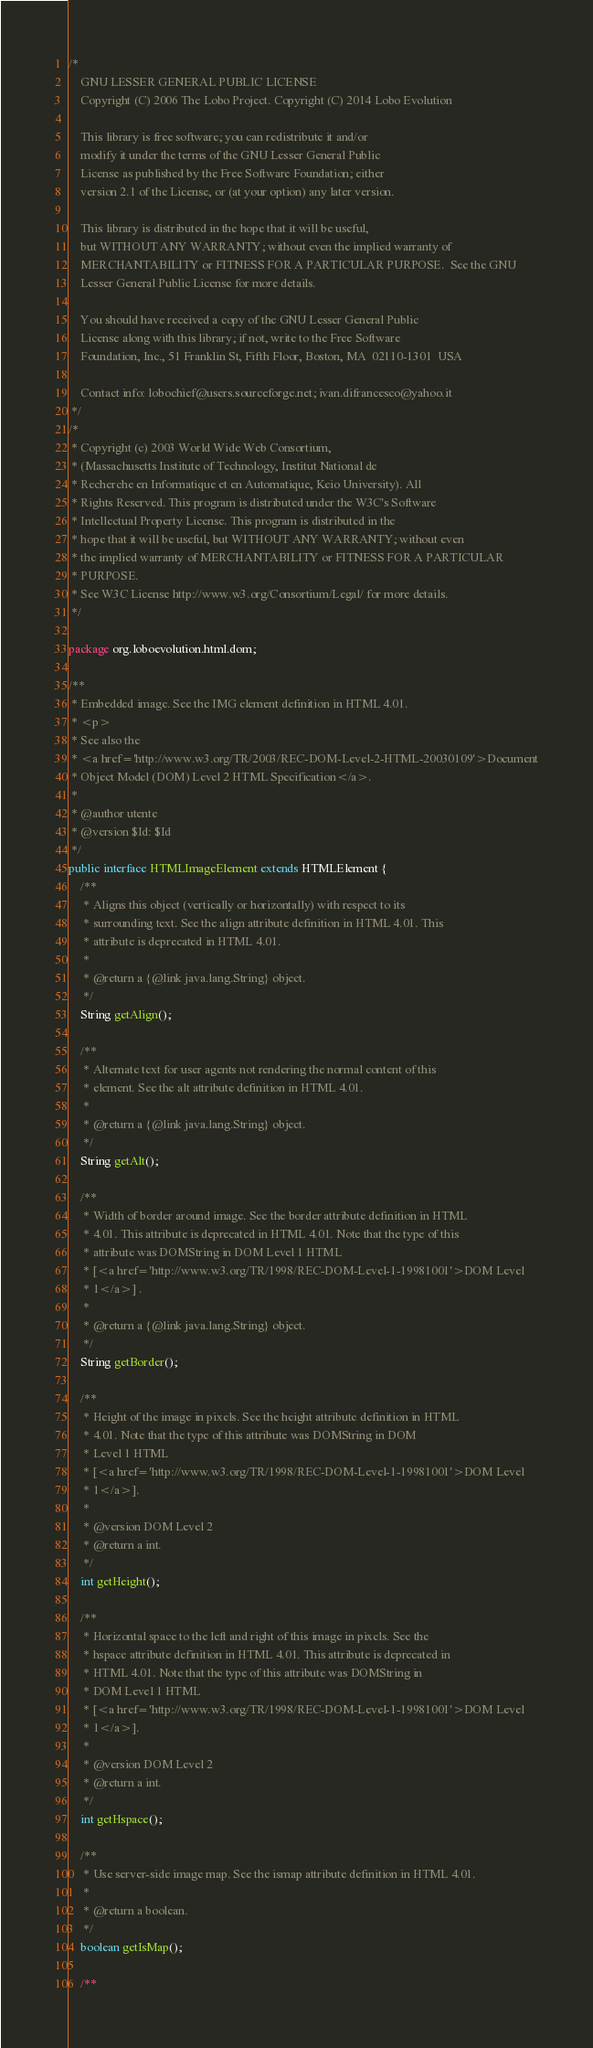Convert code to text. <code><loc_0><loc_0><loc_500><loc_500><_Java_>/*
    GNU LESSER GENERAL PUBLIC LICENSE
    Copyright (C) 2006 The Lobo Project. Copyright (C) 2014 Lobo Evolution

    This library is free software; you can redistribute it and/or
    modify it under the terms of the GNU Lesser General Public
    License as published by the Free Software Foundation; either
    version 2.1 of the License, or (at your option) any later version.

    This library is distributed in the hope that it will be useful,
    but WITHOUT ANY WARRANTY; without even the implied warranty of
    MERCHANTABILITY or FITNESS FOR A PARTICULAR PURPOSE.  See the GNU
    Lesser General Public License for more details.

    You should have received a copy of the GNU Lesser General Public
    License along with this library; if not, write to the Free Software
    Foundation, Inc., 51 Franklin St, Fifth Floor, Boston, MA  02110-1301  USA

    Contact info: lobochief@users.sourceforge.net; ivan.difrancesco@yahoo.it
 */
/*
 * Copyright (c) 2003 World Wide Web Consortium,
 * (Massachusetts Institute of Technology, Institut National de
 * Recherche en Informatique et en Automatique, Keio University). All
 * Rights Reserved. This program is distributed under the W3C's Software
 * Intellectual Property License. This program is distributed in the
 * hope that it will be useful, but WITHOUT ANY WARRANTY; without even
 * the implied warranty of MERCHANTABILITY or FITNESS FOR A PARTICULAR
 * PURPOSE.
 * See W3C License http://www.w3.org/Consortium/Legal/ for more details.
 */

package org.loboevolution.html.dom;

/**
 * Embedded image. See the IMG element definition in HTML 4.01.
 * <p>
 * See also the
 * <a href='http://www.w3.org/TR/2003/REC-DOM-Level-2-HTML-20030109'>Document
 * Object Model (DOM) Level 2 HTML Specification</a>.
 *
 * @author utente
 * @version $Id: $Id
 */
public interface HTMLImageElement extends HTMLElement {
	/**
	 * Aligns this object (vertically or horizontally) with respect to its
	 * surrounding text. See the align attribute definition in HTML 4.01. This
	 * attribute is deprecated in HTML 4.01.
	 *
	 * @return a {@link java.lang.String} object.
	 */
	String getAlign();

	/**
	 * Alternate text for user agents not rendering the normal content of this
	 * element. See the alt attribute definition in HTML 4.01.
	 *
	 * @return a {@link java.lang.String} object.
	 */
	String getAlt();

	/**
	 * Width of border around image. See the border attribute definition in HTML
	 * 4.01. This attribute is deprecated in HTML 4.01. Note that the type of this
	 * attribute was DOMString in DOM Level 1 HTML
	 * [<a href='http://www.w3.org/TR/1998/REC-DOM-Level-1-19981001'>DOM Level
	 * 1</a>] .
	 *
	 * @return a {@link java.lang.String} object.
	 */
	String getBorder();

	/**
	 * Height of the image in pixels. See the height attribute definition in HTML
	 * 4.01. Note that the type of this attribute was DOMString in DOM
	 * Level 1 HTML
	 * [<a href='http://www.w3.org/TR/1998/REC-DOM-Level-1-19981001'>DOM Level
	 * 1</a>].
	 *
	 * @version DOM Level 2
	 * @return a int.
	 */
	int getHeight();

	/**
	 * Horizontal space to the left and right of this image in pixels. See the
	 * hspace attribute definition in HTML 4.01. This attribute is deprecated in
	 * HTML 4.01. Note that the type of this attribute was DOMString in
	 * DOM Level 1 HTML
	 * [<a href='http://www.w3.org/TR/1998/REC-DOM-Level-1-19981001'>DOM Level
	 * 1</a>].
	 *
	 * @version DOM Level 2
	 * @return a int.
	 */
	int getHspace();

	/**
	 * Use server-side image map. See the ismap attribute definition in HTML 4.01.
	 *
	 * @return a boolean.
	 */
	boolean getIsMap();

	/**</code> 